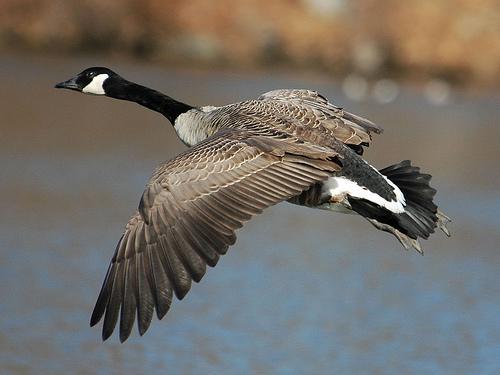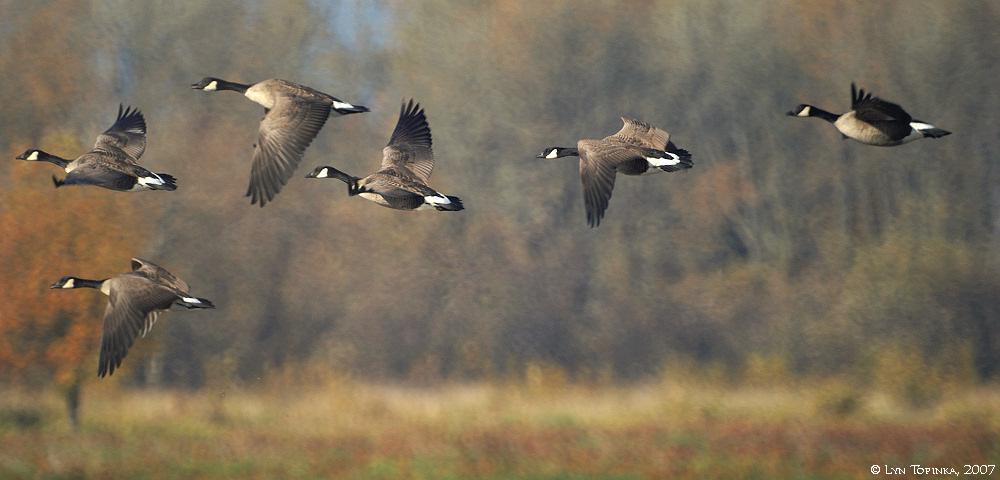The first image is the image on the left, the second image is the image on the right. Evaluate the accuracy of this statement regarding the images: "One image shows at least four black-necked geese flying leftward, and the other image shows no more than two geese flying and they do not have black necks.". Is it true? Answer yes or no. No. The first image is the image on the left, the second image is the image on the right. Analyze the images presented: Is the assertion "There is no more than two ducks in the left image." valid? Answer yes or no. Yes. 